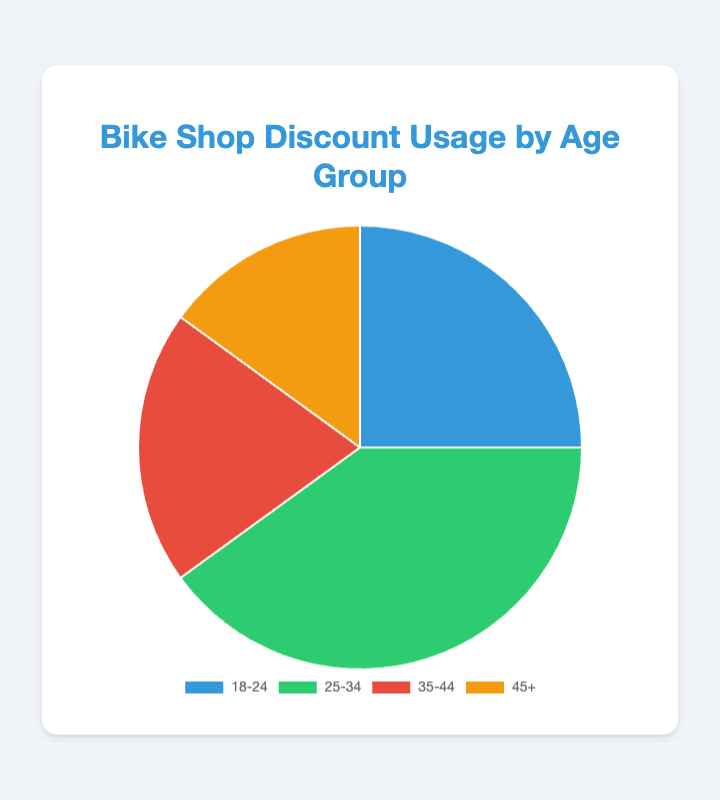What percentage of customers are in the age group 25-34? Refer to the figure and look for the label "25-34". The percentage value next to it is 40%.
Answer: 40% Which age group has the highest percentage of customers using bike shop discounts? Visually identify the largest section of the pie chart. The largest section corresponds to the 25-34 age group, which has a percentage of 40%.
Answer: 25-34 What's the combined percentage of customers in the age groups 18-24 and 35-44? Add the percentages of the age groups 18-24 and 35-44. That is 25% + 20% = 45%.
Answer: 45% How much more is the percentage of customers in the 25-34 age group than in the 45+ age group? Subtract the percentage of the 45+ age group from the 25-34 age group. That is 40% - 15% = 25%.
Answer: 25% Which age group has the smallest percentage of customers using the discounts? Visually identify the smallest section of the pie chart. The smallest section corresponds to the 45+ age group, which has a percentage of 15%.
Answer: 45+ What is the total percentage of customers that are 35 years old or older? Add the percentages of the age groups 35-44 and 45+. That is 20% + 15% = 35%.
Answer: 35% What is the difference in percentage points between the 18-24 and 35-44 age groups? Subtract the percentage of the 35-44 age group from the 18-24 age group. That is 25% - 20% = 5%.
Answer: 5% If you combine the groups 35-44 and 45+, what would be their combined share? Add the percentages of the age groups 35-44 and 45+. That is 20% + 15% = 35%.
Answer: 35% How many times larger is the percentage of customers in the 25-34 age group compared to the 45+ age group? Divide the percentage of the 25-34 age group by the percentage of the 45+ age group. That is 40% / 15% ≈ 2.67 times larger.
Answer: ≈ 2.67 times larger 